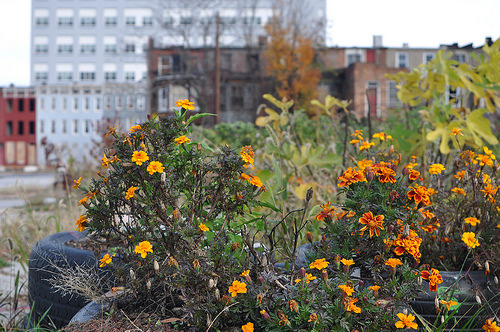<image>
Is there a building in front of the flower? No. The building is not in front of the flower. The spatial positioning shows a different relationship between these objects. 